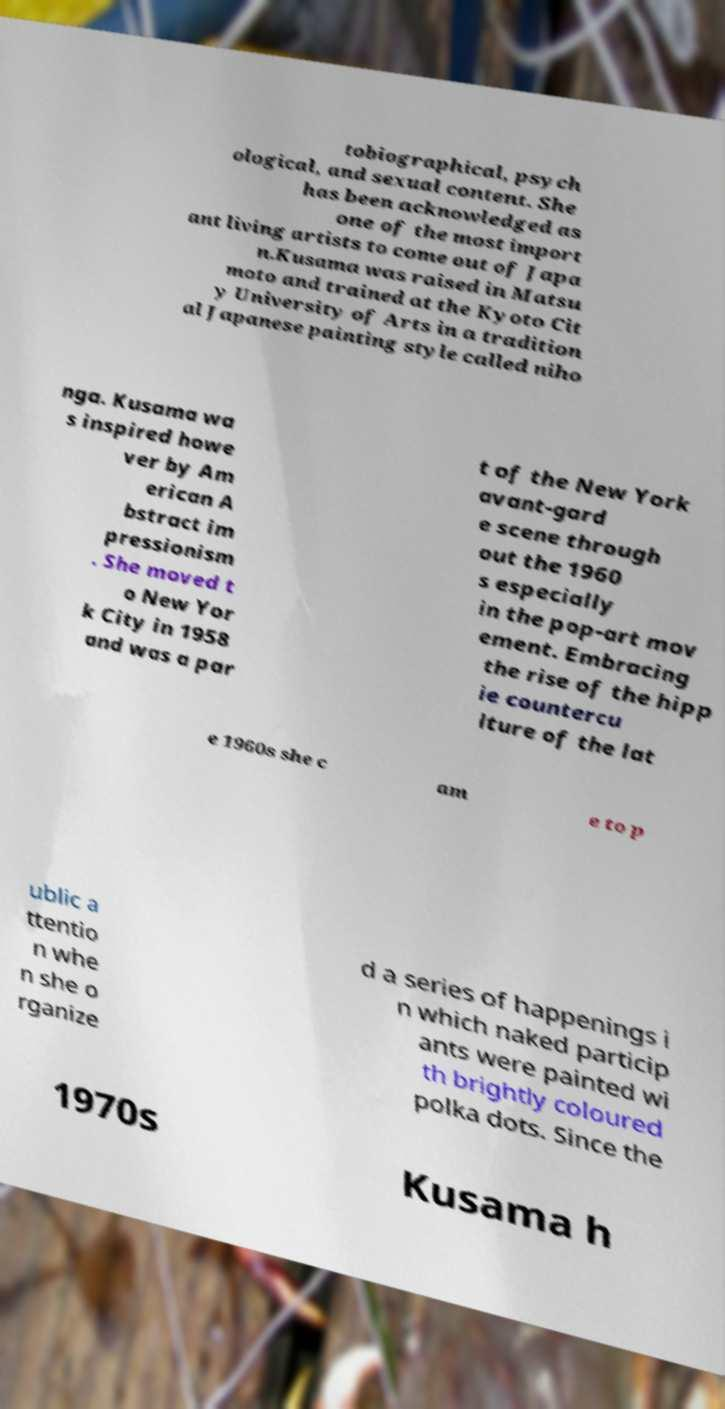For documentation purposes, I need the text within this image transcribed. Could you provide that? tobiographical, psych ological, and sexual content. She has been acknowledged as one of the most import ant living artists to come out of Japa n.Kusama was raised in Matsu moto and trained at the Kyoto Cit y University of Arts in a tradition al Japanese painting style called niho nga. Kusama wa s inspired howe ver by Am erican A bstract im pressionism . She moved t o New Yor k City in 1958 and was a par t of the New York avant-gard e scene through out the 1960 s especially in the pop-art mov ement. Embracing the rise of the hipp ie countercu lture of the lat e 1960s she c am e to p ublic a ttentio n whe n she o rganize d a series of happenings i n which naked particip ants were painted wi th brightly coloured polka dots. Since the 1970s Kusama h 